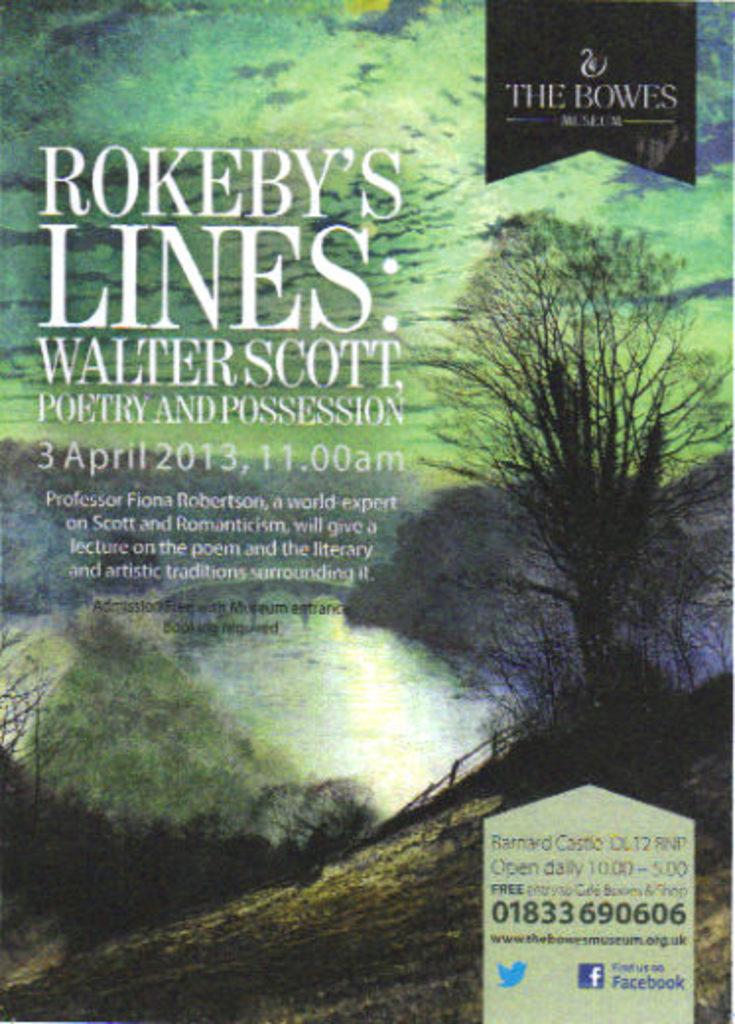What is the date of the poetry event by walter scott?
Your answer should be compact. 3 april 2013. What is professor fiona robertson an expert in?
Your answer should be compact. Scott and romanticism. 